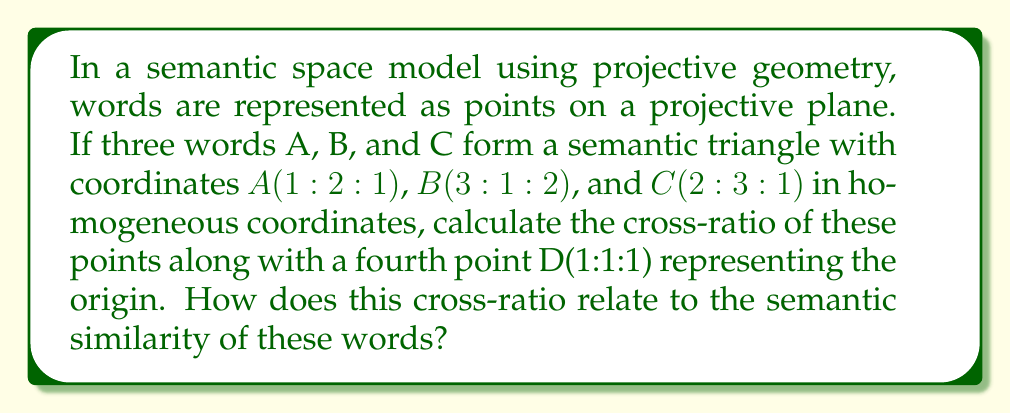Give your solution to this math problem. To solve this problem, we'll follow these steps:

1) Recall that the cross-ratio of four collinear points A, B, C, D is defined as:

   $$(A,B;C,D) = \frac{AC \cdot BD}{AD \cdot BC}$$

   where AC, BD, AD, and BC are the distances between the respective points.

2) In projective geometry, we can calculate the cross-ratio using determinants:

   $$(A,B;C,D) = \frac{|ADC||BCD|}{|ACD||BDC|}$$

   where |ABC| denotes the determinant of the matrix formed by the homogeneous coordinates of A, B, and C.

3) Let's calculate each determinant:

   $$|ADC| = \begin{vmatrix}
   1 & 1 & 2 \\
   2 & 1 & 3 \\
   1 & 1 & 1
   \end{vmatrix} = 1 - 2 = -1$$

   $$|BCD| = \begin{vmatrix}
   3 & 1 & 2 \\
   1 & 1 & 3 \\
   2 & 1 & 1
   \end{vmatrix} = 3 - 4 = -1$$

   $$|ACD| = \begin{vmatrix}
   1 & 2 & 1 \\
   2 & 3 & 1 \\
   1 & 1 & 1
   \end{vmatrix} = 1 - 1 = 0$$

   $$|BDC| = \begin{vmatrix}
   3 & 1 & 2 \\
   1 & 1 & 1 \\
   2 & 3 & 1
   \end{vmatrix} = 3 - 5 = -2$$

4) Now we can calculate the cross-ratio:

   $$(A,B;C,D) = \frac{(-1)(-1)}{(0)(-2)} = \frac{1}{0}$$

5) The result is undefined, which means that the four points are not collinear in the projective plane. This is expected, as we started with a semantic triangle.

6) In terms of semantic similarity, this result suggests that the four words cannot be arranged in a linear semantic relationship. The fact that A, B, and C form a triangle indicates that they represent distinct semantic concepts that cannot be reduced to a single dimension.

7) The undefined cross-ratio implies that the semantic relationships between these words are complex and multidimensional, which aligns with the nature of natural language semantics.
Answer: Undefined; indicates complex, non-linear semantic relationships 